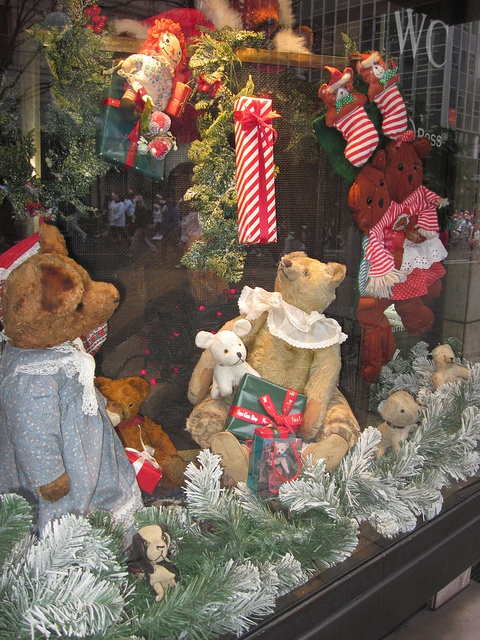Describe the objects in this image and their specific colors. I can see teddy bear in black, darkgray, gray, and brown tones, teddy bear in black, tan, gray, and ivory tones, teddy bear in black, maroon, brown, and darkgray tones, teddy bear in black, maroon, darkgray, and brown tones, and teddy bear in black, brown, maroon, and gray tones in this image. 